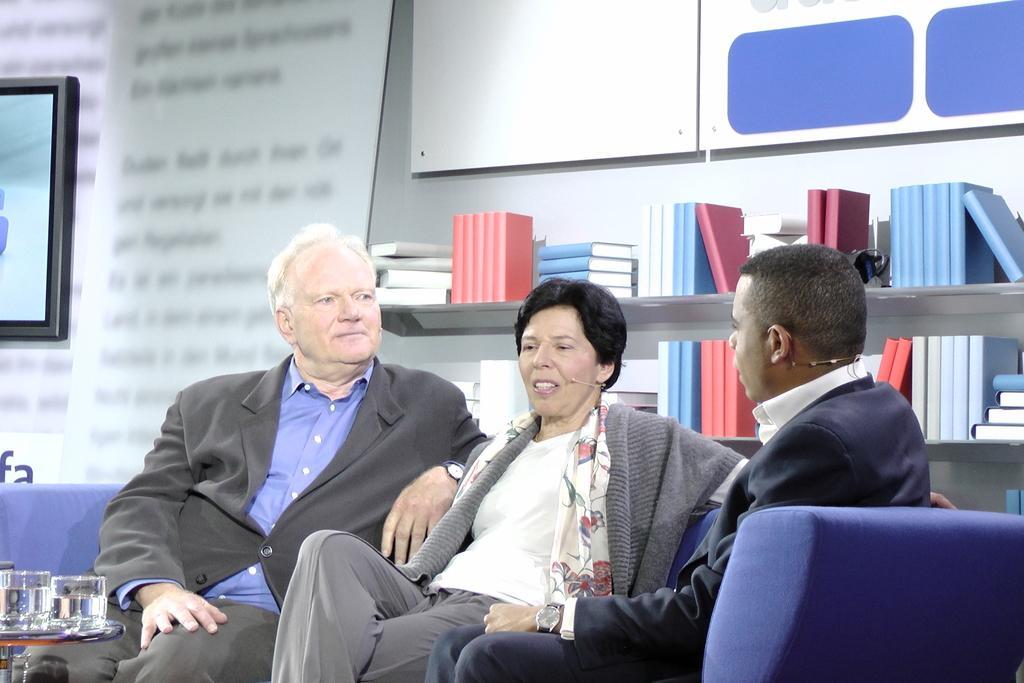How would you summarize this image in a sentence or two? In this image I can see three people sitting on the couch. These people are wearing the different color dresses and the couch is in purple color. In the back there are books in the rack. To the left I can see the screen and there is a board in the back. 